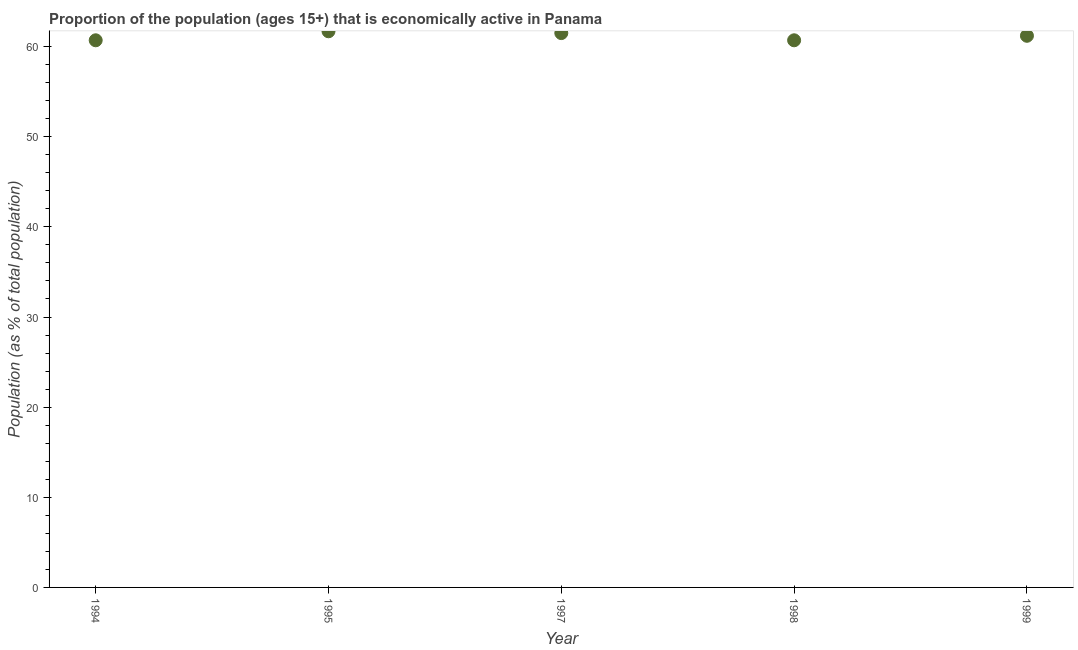What is the percentage of economically active population in 1997?
Make the answer very short. 61.5. Across all years, what is the maximum percentage of economically active population?
Give a very brief answer. 61.7. Across all years, what is the minimum percentage of economically active population?
Offer a very short reply. 60.7. In which year was the percentage of economically active population maximum?
Provide a short and direct response. 1995. In which year was the percentage of economically active population minimum?
Your answer should be very brief. 1994. What is the sum of the percentage of economically active population?
Keep it short and to the point. 305.8. What is the average percentage of economically active population per year?
Make the answer very short. 61.16. What is the median percentage of economically active population?
Offer a terse response. 61.2. What is the ratio of the percentage of economically active population in 1994 to that in 1998?
Ensure brevity in your answer.  1. What is the difference between the highest and the second highest percentage of economically active population?
Your answer should be compact. 0.2. Is the sum of the percentage of economically active population in 1997 and 1999 greater than the maximum percentage of economically active population across all years?
Offer a very short reply. Yes. What is the difference between the highest and the lowest percentage of economically active population?
Provide a succinct answer. 1. What is the difference between two consecutive major ticks on the Y-axis?
Ensure brevity in your answer.  10. Are the values on the major ticks of Y-axis written in scientific E-notation?
Your response must be concise. No. What is the title of the graph?
Give a very brief answer. Proportion of the population (ages 15+) that is economically active in Panama. What is the label or title of the Y-axis?
Keep it short and to the point. Population (as % of total population). What is the Population (as % of total population) in 1994?
Provide a short and direct response. 60.7. What is the Population (as % of total population) in 1995?
Offer a terse response. 61.7. What is the Population (as % of total population) in 1997?
Offer a very short reply. 61.5. What is the Population (as % of total population) in 1998?
Ensure brevity in your answer.  60.7. What is the Population (as % of total population) in 1999?
Ensure brevity in your answer.  61.2. What is the difference between the Population (as % of total population) in 1994 and 1995?
Ensure brevity in your answer.  -1. What is the difference between the Population (as % of total population) in 1994 and 1999?
Give a very brief answer. -0.5. What is the difference between the Population (as % of total population) in 1997 and 1998?
Ensure brevity in your answer.  0.8. What is the difference between the Population (as % of total population) in 1997 and 1999?
Your answer should be very brief. 0.3. What is the ratio of the Population (as % of total population) in 1994 to that in 1997?
Keep it short and to the point. 0.99. What is the ratio of the Population (as % of total population) in 1995 to that in 1999?
Give a very brief answer. 1.01. 